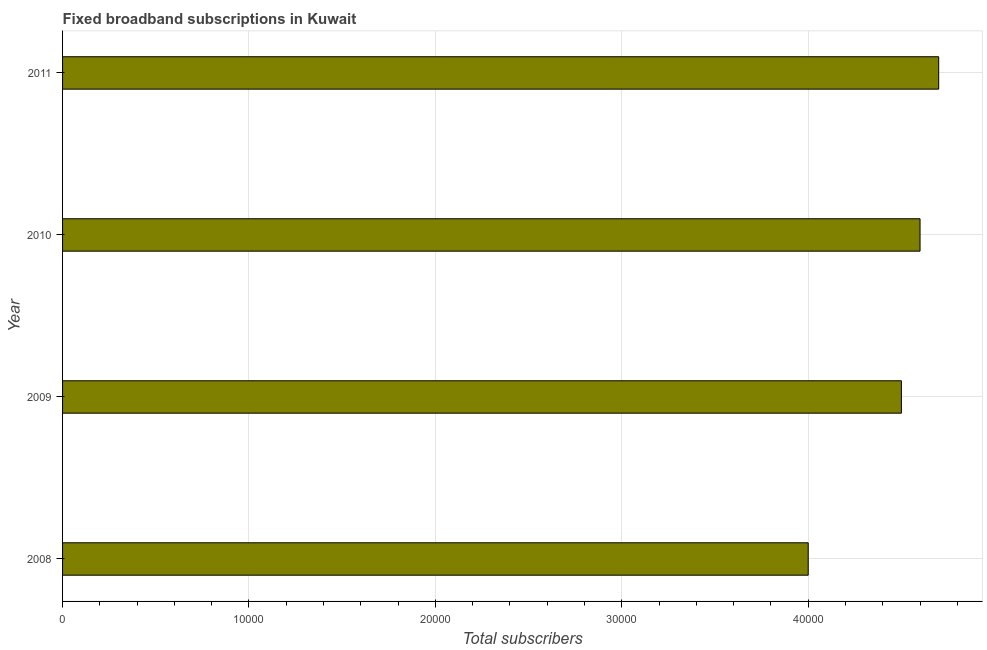Does the graph contain any zero values?
Make the answer very short. No. What is the title of the graph?
Make the answer very short. Fixed broadband subscriptions in Kuwait. What is the label or title of the X-axis?
Your answer should be very brief. Total subscribers. What is the label or title of the Y-axis?
Provide a short and direct response. Year. What is the total number of fixed broadband subscriptions in 2010?
Provide a short and direct response. 4.60e+04. Across all years, what is the maximum total number of fixed broadband subscriptions?
Keep it short and to the point. 4.70e+04. In which year was the total number of fixed broadband subscriptions maximum?
Give a very brief answer. 2011. What is the sum of the total number of fixed broadband subscriptions?
Provide a succinct answer. 1.78e+05. What is the difference between the total number of fixed broadband subscriptions in 2009 and 2011?
Offer a terse response. -2000. What is the average total number of fixed broadband subscriptions per year?
Your answer should be very brief. 4.45e+04. What is the median total number of fixed broadband subscriptions?
Make the answer very short. 4.55e+04. What is the ratio of the total number of fixed broadband subscriptions in 2008 to that in 2009?
Keep it short and to the point. 0.89. Is the total number of fixed broadband subscriptions in 2009 less than that in 2011?
Provide a short and direct response. Yes. Is the sum of the total number of fixed broadband subscriptions in 2009 and 2010 greater than the maximum total number of fixed broadband subscriptions across all years?
Provide a succinct answer. Yes. What is the difference between the highest and the lowest total number of fixed broadband subscriptions?
Ensure brevity in your answer.  7000. Are all the bars in the graph horizontal?
Offer a terse response. Yes. How many years are there in the graph?
Make the answer very short. 4. Are the values on the major ticks of X-axis written in scientific E-notation?
Your answer should be compact. No. What is the Total subscribers in 2009?
Your response must be concise. 4.50e+04. What is the Total subscribers of 2010?
Ensure brevity in your answer.  4.60e+04. What is the Total subscribers of 2011?
Make the answer very short. 4.70e+04. What is the difference between the Total subscribers in 2008 and 2009?
Provide a succinct answer. -5000. What is the difference between the Total subscribers in 2008 and 2010?
Make the answer very short. -6000. What is the difference between the Total subscribers in 2008 and 2011?
Provide a short and direct response. -7000. What is the difference between the Total subscribers in 2009 and 2010?
Your answer should be compact. -1000. What is the difference between the Total subscribers in 2009 and 2011?
Ensure brevity in your answer.  -2000. What is the difference between the Total subscribers in 2010 and 2011?
Offer a terse response. -1000. What is the ratio of the Total subscribers in 2008 to that in 2009?
Ensure brevity in your answer.  0.89. What is the ratio of the Total subscribers in 2008 to that in 2010?
Your answer should be compact. 0.87. What is the ratio of the Total subscribers in 2008 to that in 2011?
Offer a terse response. 0.85. 